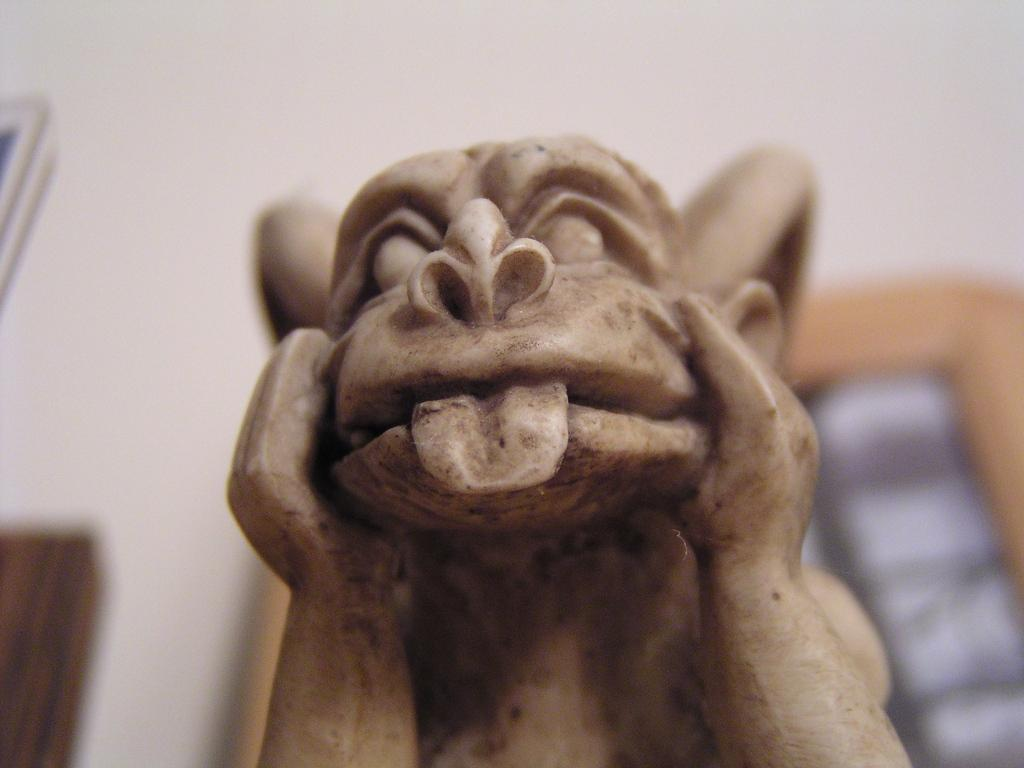What is the main subject of the picture? The main subject of the picture is a monkey sculpture. Can you describe the surroundings of the image? The surroundings of the image are slightly blurred. What type of organization is depicted in the image? There is no organization depicted in the image; it features a monkey sculpture. What kind of spark can be seen coming from the monkey sculpture in the image? There is no spark present in the image; it only features a monkey sculpture and slightly blurred surroundings. 